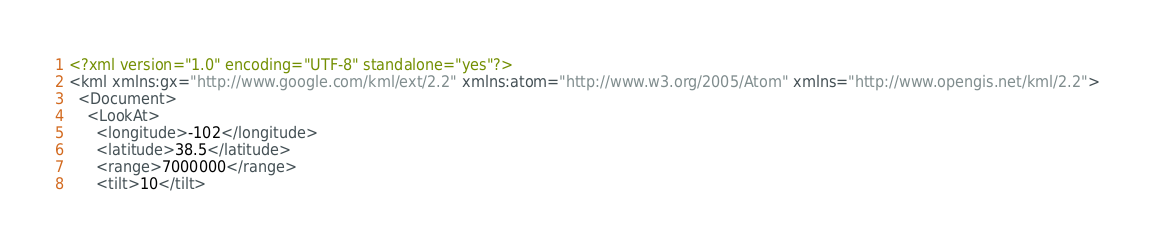Convert code to text. <code><loc_0><loc_0><loc_500><loc_500><_XML_><?xml version="1.0" encoding="UTF-8" standalone="yes"?>
<kml xmlns:gx="http://www.google.com/kml/ext/2.2" xmlns:atom="http://www.w3.org/2005/Atom" xmlns="http://www.opengis.net/kml/2.2">
  <Document>
    <LookAt>
      <longitude>-102</longitude>
      <latitude>38.5</latitude>
      <range>7000000</range>
      <tilt>10</tilt></code> 